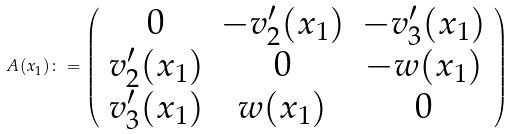<formula> <loc_0><loc_0><loc_500><loc_500>A ( x _ { 1 } ) \colon = \left ( \begin{array} { c c c } 0 & - v _ { 2 } ^ { \prime } ( x _ { 1 } ) & - v _ { 3 } ^ { \prime } ( x _ { 1 } ) \\ v _ { 2 } ^ { \prime } ( x _ { 1 } ) & 0 & - w ( x _ { 1 } ) \\ v _ { 3 } ^ { \prime } ( x _ { 1 } ) & w ( x _ { 1 } ) & 0 \end{array} \right )</formula> 